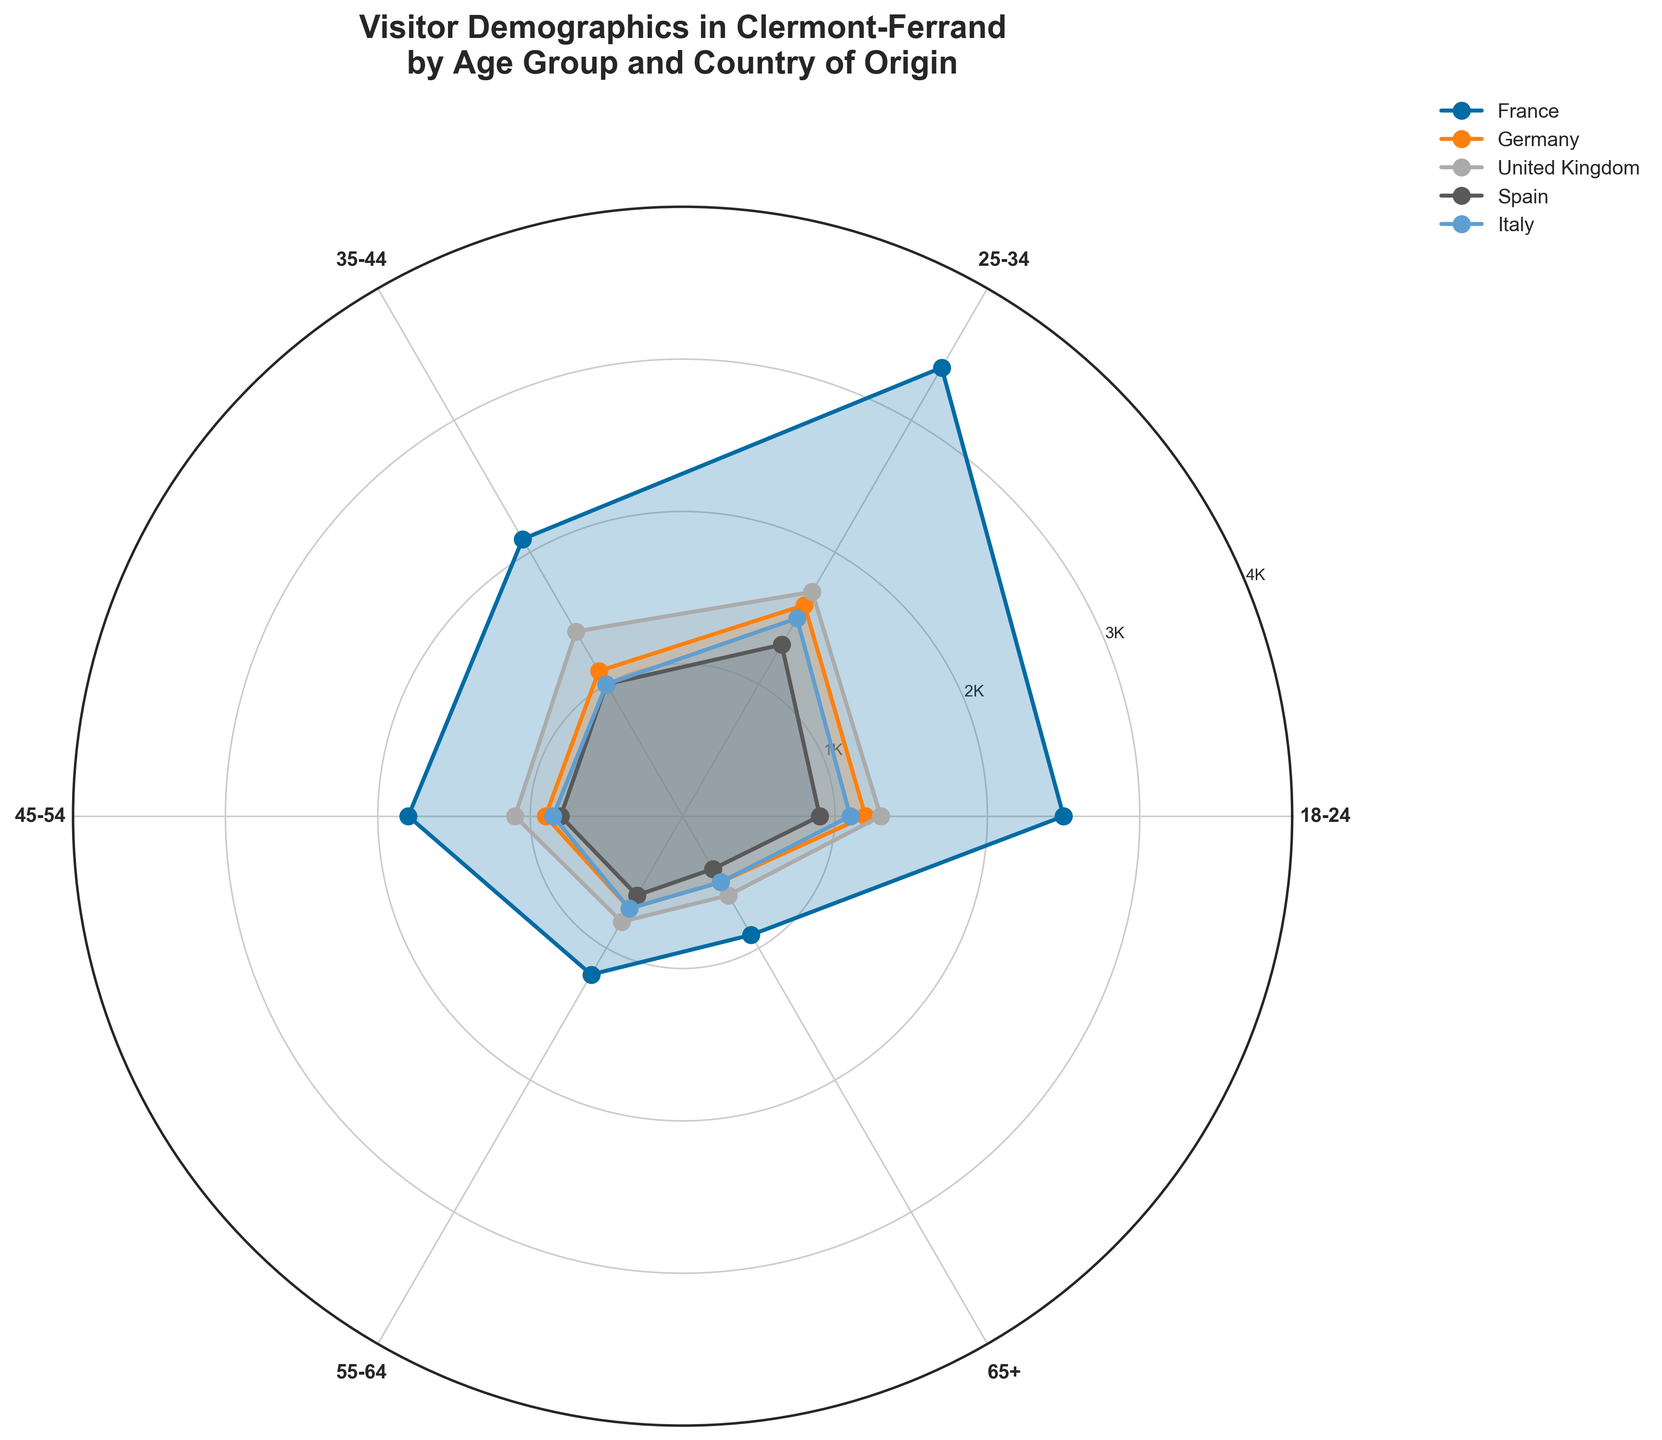What is the title of the figure? The title of the figure is displayed at the top and usually gives a brief description of what the chart represents.
Answer: Visitor Demographics in Clermont-Ferrand by Age Group and Country of Origin How many age groups are there in the figure? Count the distinct age group labels on the chart.
Answer: 6 Which country has the highest number of visitors in the 25-34 age group? Compare the lengths of the lines for the 25-34 age group among all countries.
Answer: France Is the number of visitors from the United Kingdom in the 55-64 age group more or less than 1000? Look at the point corresponding to the United Kingdom on the 55-64 age group line and see if it falls above or below the 1000 mark on the radial axis.
Answer: Less What is the difference in the number of visitors between the 18-24 and 65+ age groups for Germany? Subtract the number of visitors in the 65+ age group from those in the 18-24 age group for Germany. 1200 - 500 = 700
Answer: 700 Which country has the smallest number of visitors in any age group, and what is that number? Find the smallest number in the data table, then identify the corresponding country and age group on the chart.
Answer: Spain, 65+, 400 Does Spain have more visitors in the 25-34 age group than Germany? Compare the lengths of the 25-34 age group lines for Spain and Germany on the chart.
Answer: No What is the median number of visitors for the age group 35-44 across all countries? Arrange the numbers for visitors in the 35-44 age group across France, Germany, United Kingdom, Spain, and Italy in ascending order (1000, 1000, 1100, 1400, 2100). The median is the middle value.
Answer: 1100 How does the number of visitors from Italy in the 45-54 age group compare to the corresponding number from Spain? Look at the lengths of the lines for the 45-54 age group for Italy and Spain and compare them.
Answer: More What is the total number of visitors from all countries in the 65+ age group? Sum the numbers of visitors in the 65+ age group for France, Germany, United Kingdom, Spain, and Italy. 900 + 500 + 600 + 400 + 500 = 2900
Answer: 2900 